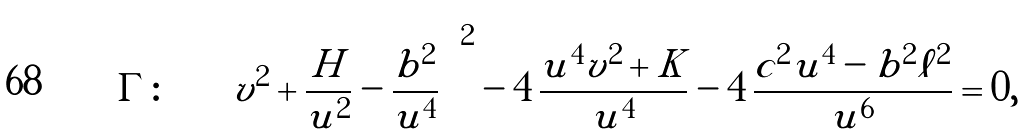<formula> <loc_0><loc_0><loc_500><loc_500>\Gamma \colon \quad \left ( v ^ { 2 } + \frac { H } { u ^ { 2 } } - \frac { b ^ { 2 } } { u ^ { 4 } } \right ) ^ { 2 } - 4 \, \frac { u ^ { 4 } v ^ { 2 } + K } { u ^ { 4 } } - 4 \, \frac { c ^ { 2 } u ^ { 4 } - b ^ { 2 } \ell ^ { 2 } } { u ^ { 6 } } = 0 ,</formula> 